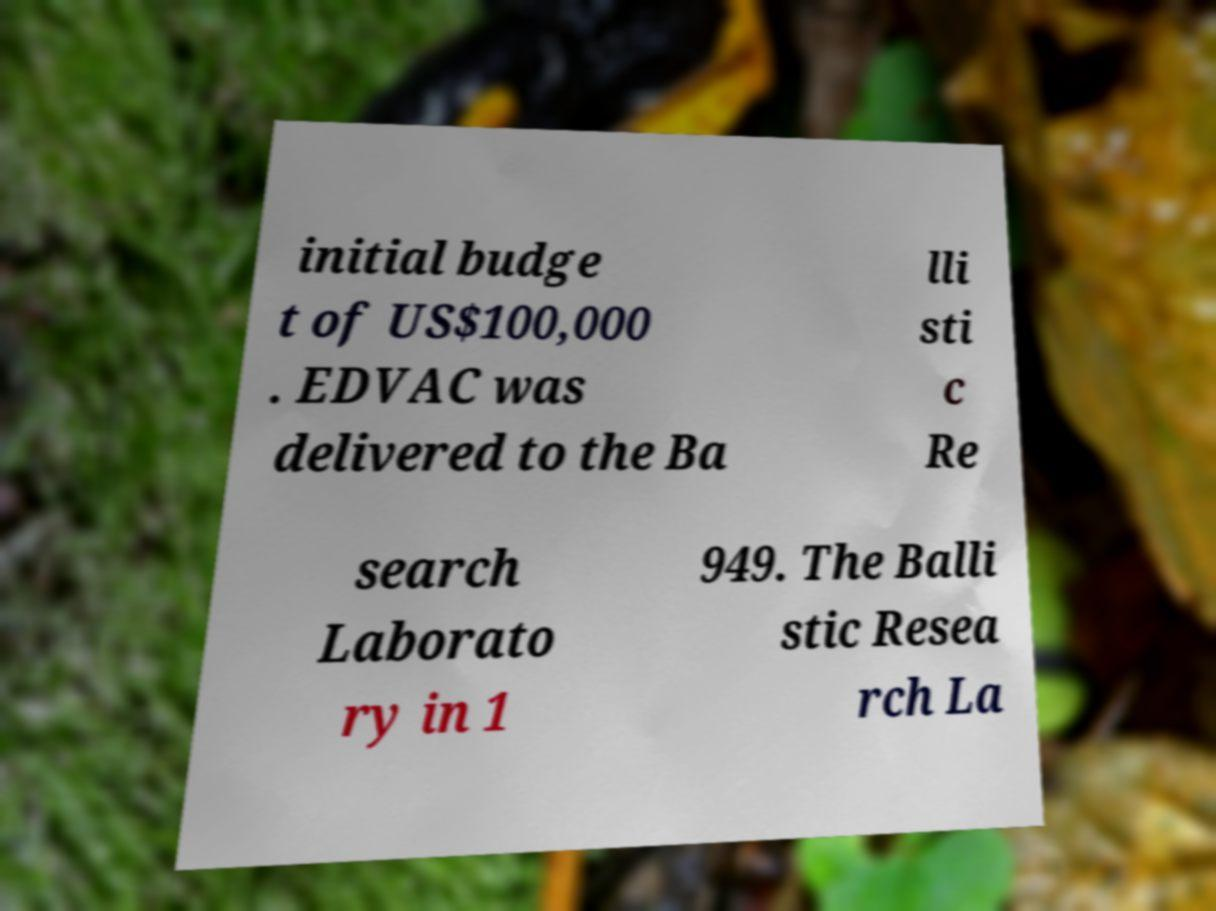There's text embedded in this image that I need extracted. Can you transcribe it verbatim? initial budge t of US$100,000 . EDVAC was delivered to the Ba lli sti c Re search Laborato ry in 1 949. The Balli stic Resea rch La 